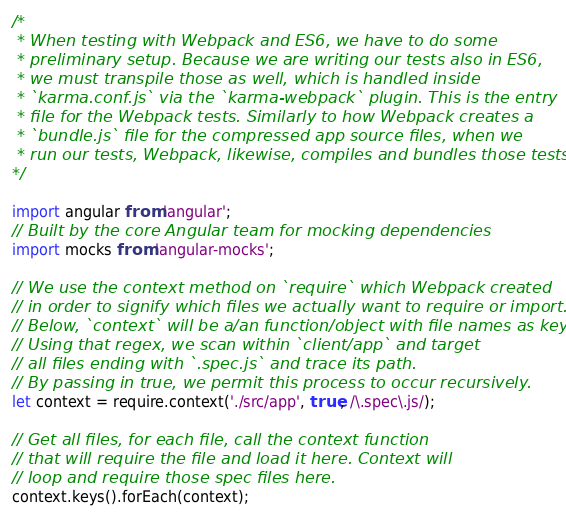<code> <loc_0><loc_0><loc_500><loc_500><_JavaScript_>/*
 * When testing with Webpack and ES6, we have to do some
 * preliminary setup. Because we are writing our tests also in ES6,
 * we must transpile those as well, which is handled inside
 * `karma.conf.js` via the `karma-webpack` plugin. This is the entry
 * file for the Webpack tests. Similarly to how Webpack creates a
 * `bundle.js` file for the compressed app source files, when we
 * run our tests, Webpack, likewise, compiles and bundles those tests here.
*/

import angular from 'angular';
// Built by the core Angular team for mocking dependencies
import mocks from 'angular-mocks';

// We use the context method on `require` which Webpack created
// in order to signify which files we actually want to require or import.
// Below, `context` will be a/an function/object with file names as keys.
// Using that regex, we scan within `client/app` and target
// all files ending with `.spec.js` and trace its path.
// By passing in true, we permit this process to occur recursively.
let context = require.context('./src/app', true, /\.spec\.js/);

// Get all files, for each file, call the context function
// that will require the file and load it here. Context will
// loop and require those spec files here.
context.keys().forEach(context);
</code> 